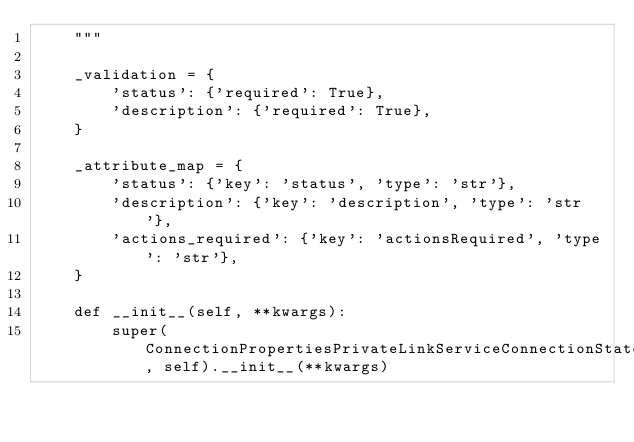<code> <loc_0><loc_0><loc_500><loc_500><_Python_>    """

    _validation = {
        'status': {'required': True},
        'description': {'required': True},
    }

    _attribute_map = {
        'status': {'key': 'status', 'type': 'str'},
        'description': {'key': 'description', 'type': 'str'},
        'actions_required': {'key': 'actionsRequired', 'type': 'str'},
    }

    def __init__(self, **kwargs):
        super(ConnectionPropertiesPrivateLinkServiceConnectionState, self).__init__(**kwargs)
</code> 